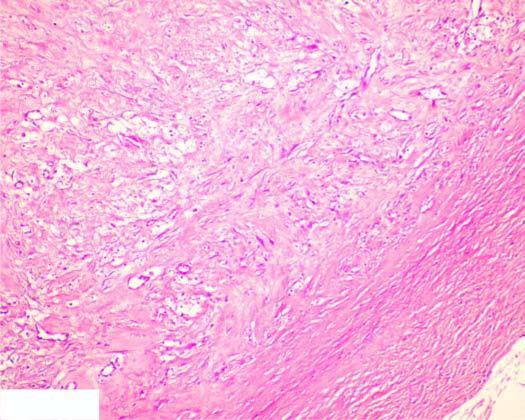what is composed of mature collagenised fibrous connective tissue?
Answer the question using a single word or phrase. Circumscribed lesion 